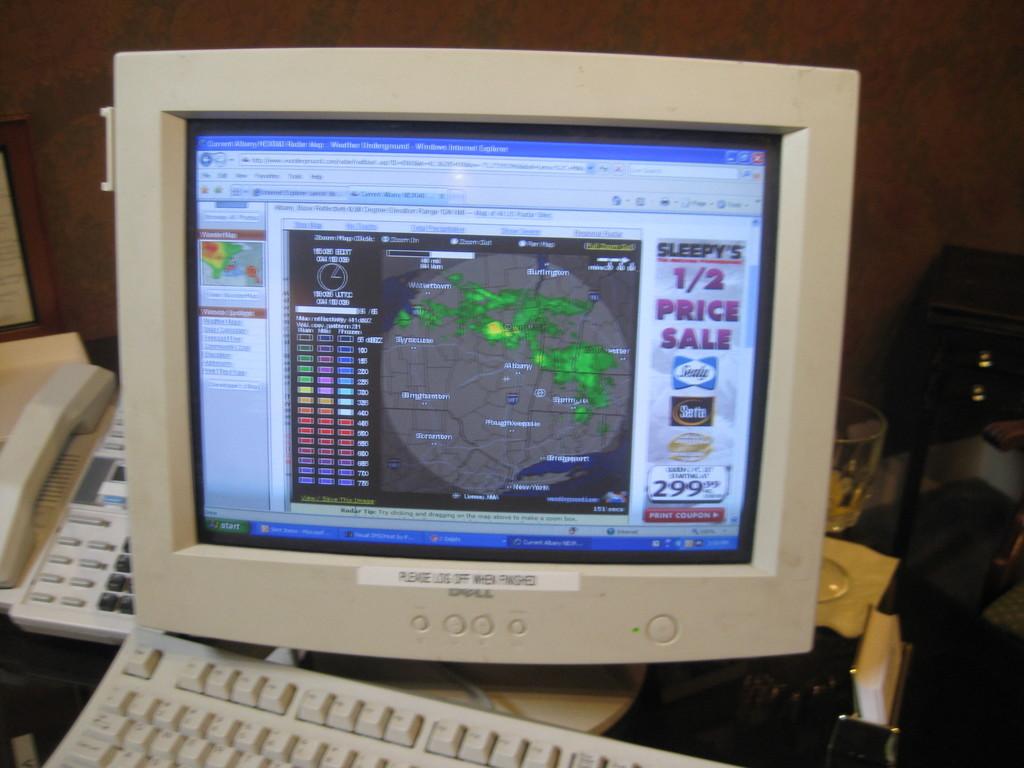What is the brand of this monitor / computer?
Provide a short and direct response. Dell. What type of sale is the ad on the right?
Your answer should be very brief. 1/2 price sale. 